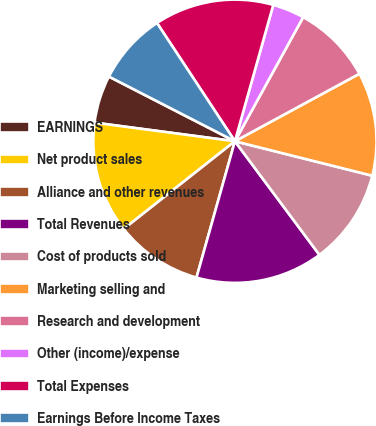Convert chart. <chart><loc_0><loc_0><loc_500><loc_500><pie_chart><fcel>EARNINGS<fcel>Net product sales<fcel>Alliance and other revenues<fcel>Total Revenues<fcel>Cost of products sold<fcel>Marketing selling and<fcel>Research and development<fcel>Other (income)/expense<fcel>Total Expenses<fcel>Earnings Before Income Taxes<nl><fcel>5.45%<fcel>12.73%<fcel>10.0%<fcel>14.55%<fcel>10.91%<fcel>11.82%<fcel>9.09%<fcel>3.64%<fcel>13.64%<fcel>8.18%<nl></chart> 